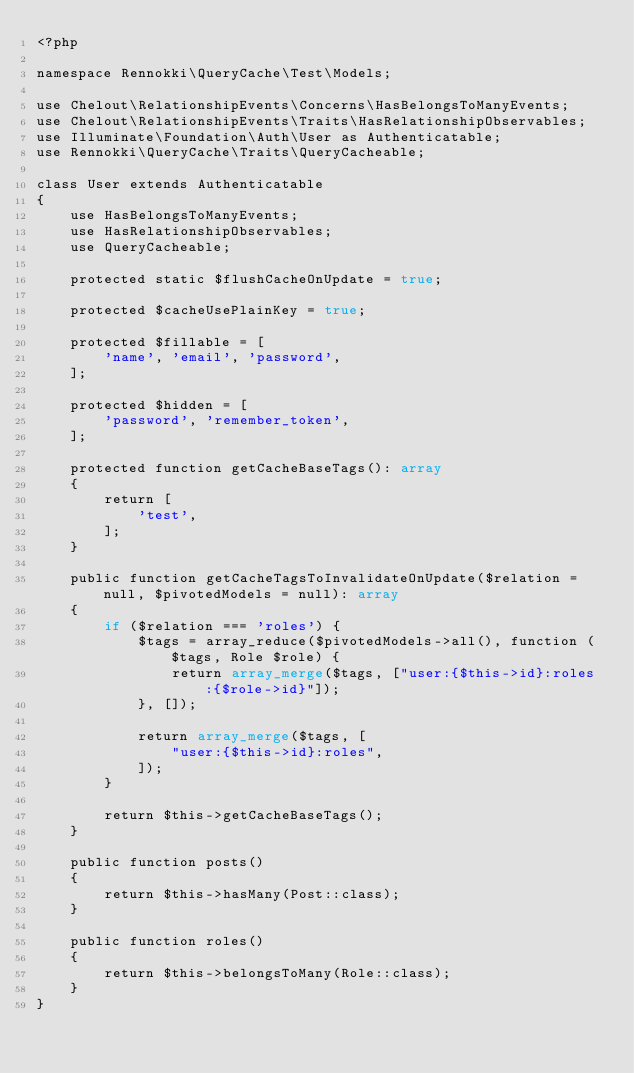<code> <loc_0><loc_0><loc_500><loc_500><_PHP_><?php

namespace Rennokki\QueryCache\Test\Models;

use Chelout\RelationshipEvents\Concerns\HasBelongsToManyEvents;
use Chelout\RelationshipEvents\Traits\HasRelationshipObservables;
use Illuminate\Foundation\Auth\User as Authenticatable;
use Rennokki\QueryCache\Traits\QueryCacheable;

class User extends Authenticatable
{
    use HasBelongsToManyEvents;
    use HasRelationshipObservables;
    use QueryCacheable;

    protected static $flushCacheOnUpdate = true;

    protected $cacheUsePlainKey = true;

    protected $fillable = [
        'name', 'email', 'password',
    ];

    protected $hidden = [
        'password', 'remember_token',
    ];

    protected function getCacheBaseTags(): array
    {
        return [
            'test',
        ];
    }

    public function getCacheTagsToInvalidateOnUpdate($relation = null, $pivotedModels = null): array
    {
        if ($relation === 'roles') {
            $tags = array_reduce($pivotedModels->all(), function ($tags, Role $role) {
                return array_merge($tags, ["user:{$this->id}:roles:{$role->id}"]);
            }, []);

            return array_merge($tags, [
                "user:{$this->id}:roles",
            ]);
        }

        return $this->getCacheBaseTags();
    }

    public function posts()
    {
        return $this->hasMany(Post::class);
    }

    public function roles()
    {
        return $this->belongsToMany(Role::class);
    }
}
</code> 